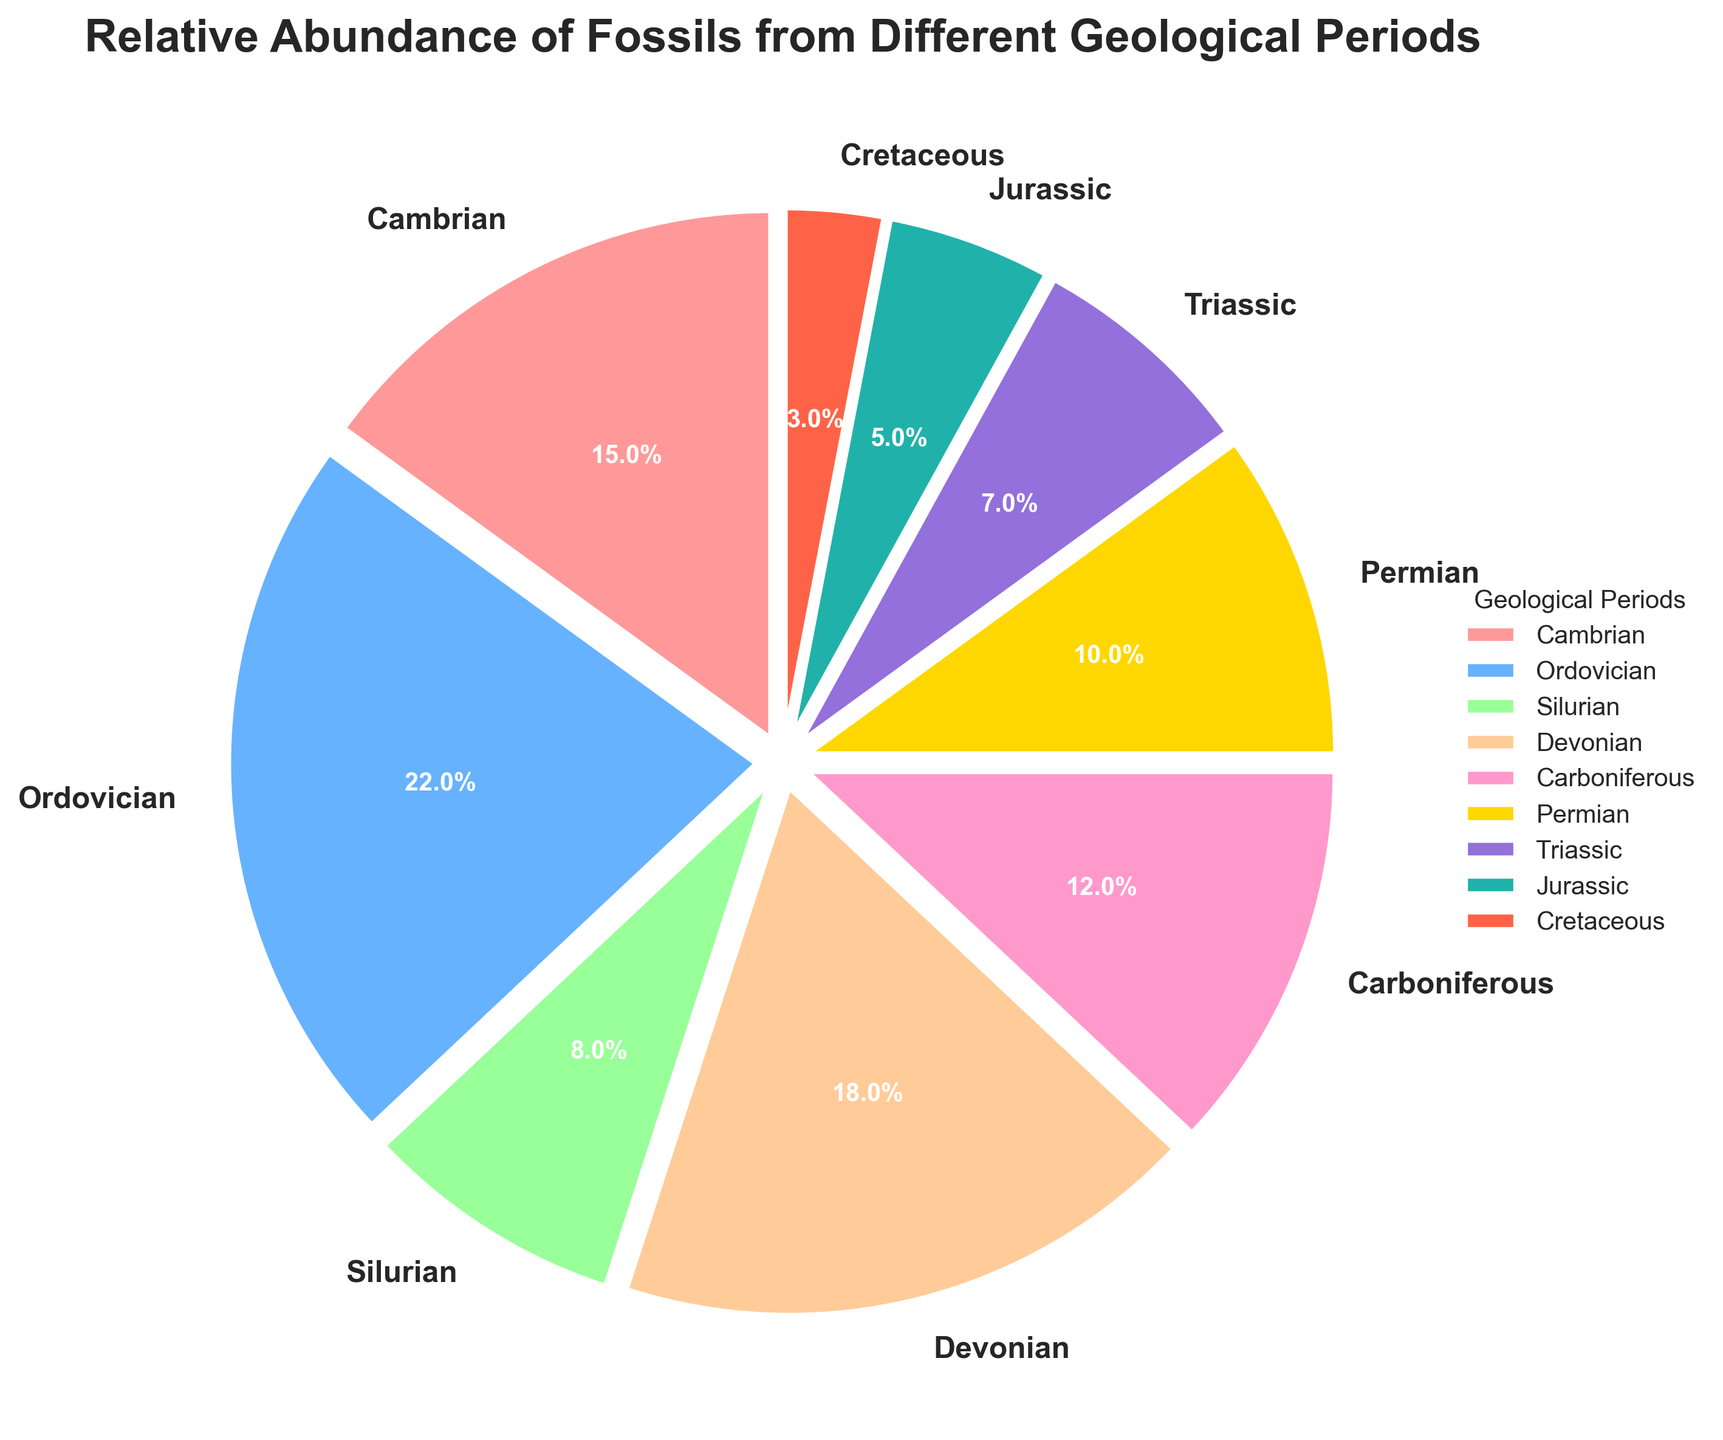What geological period has the highest relative abundance of fossils? The pie chart shows that the largest slice corresponds to the Ordovician period.
Answer: Ordovician What is the combined percentage of fossils from the Devonian and Carboniferous periods? The percentage for the Devonian is 18% and for the Carboniferous, it is 12%. Summing these two values gives 18% + 12% = 30%.
Answer: 30% How does the abundance of fossils from the Cambrian period compare to that from the Permian period? The Cambrian period has a slice representing 15%, while the Permian period has a slice representing 10%. Therefore, fossils from the Cambrian period are more abundant.
Answer: Cambrian is more abundant What two periods together contribute to 25% of the fossil abundance? The percentage for the Silurian period is 8% and for the Triassic period, it is 7%. Adding these two values gives 8% + 7% = 15%, which is too low. The Cambrian (15%) and Cretaceous (3%) sum up to 18%, also insufficient. The Permian (10%) and Triassic (7%) give 17%, still insufficient. The Cambrian (15%) and Permian (10%) combined give exactly 25%.
Answer: Cambrian and Permian Which periods contribute less than 10% each to the total fossil abundance? The slices for the Silurian, Triassic, Jurassic, and Cretaceous periods are all less than 10%.
Answer: Silurian, Triassic, Jurassic, Cretaceous What proportion of the total fossil abundance is contributed by periods from the Paleozoic era (Cambrian, Ordovician, Silurian, Devonian, Carboniferous, Permian)? The total percentages for Cambrian (15%), Ordovician (22%), Silurian (8%), Devonian (18%), Carboniferous (12%), and Permian (10%) sum up to 85%.
Answer: 85% How much larger is the fossil percentage of the Ordovician period compared to the Jurassic period? The Ordovician period has a percentage of 22%, while the Jurassic period has 5%. The difference between them is 22% - 5% = 17%.
Answer: 17% Which period has the smallest percentage of fossils and what is the exact percentage? The smallest slice in the pie chart represents the Cretaceous period, with a percentage of 3%.
Answer: Cretaceous, 3% What is the difference in fossil abundance between the Devonian and Silurian periods? The Devonian period has 18% and the Silurian period has 8%. The difference is calculated as 18% - 8% = 10%.
Answer: 10% 